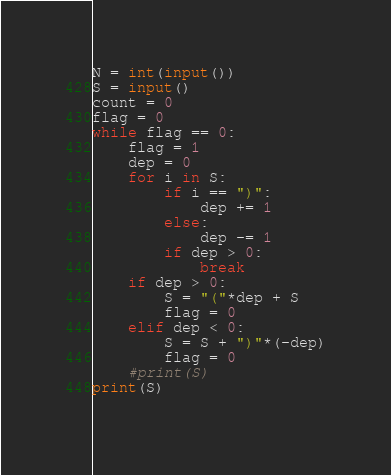<code> <loc_0><loc_0><loc_500><loc_500><_Python_>N = int(input())
S = input()
count = 0
flag = 0
while flag == 0:
    flag = 1
    dep = 0
    for i in S:
        if i == ")":
            dep += 1
        else:
            dep -= 1
        if dep > 0:
            break
    if dep > 0:
        S = "("*dep + S
        flag = 0
    elif dep < 0:
        S = S + ")"*(-dep)
        flag = 0
    #print(S)
print(S)
    </code> 